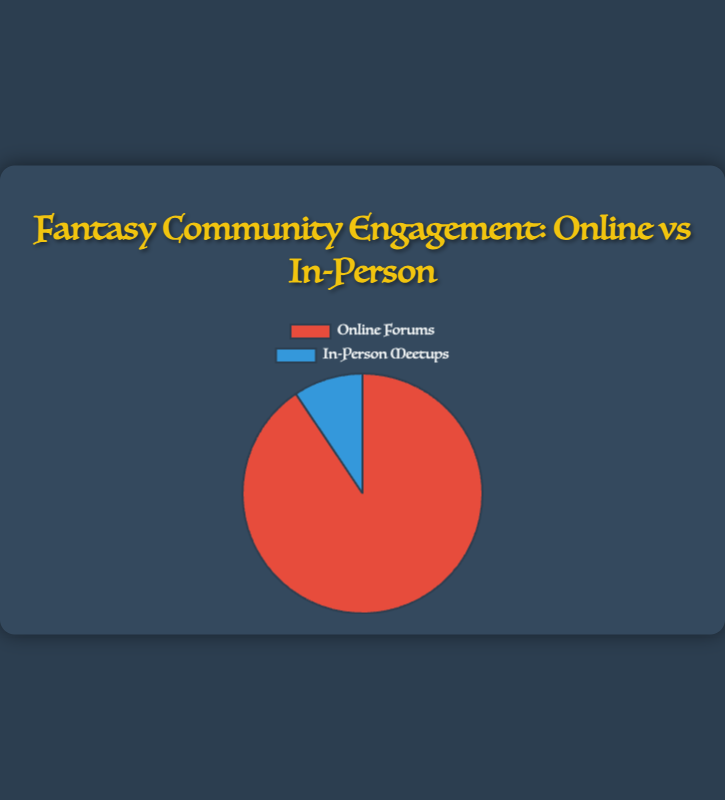What type of engagement has the highest average daily engagements? The pie chart shows two types of engagement: Online Forums and In-Person Meetups. Online Forums show a slice of the pie that is larger compared to the In-Person Meetups slice, indicating higher engagement.
Answer: Online Forums What is the total average daily engagement if you sum both Online Forums and In-Person Meetups? To find the total, you sum the average daily engagements for both categories: 14,000 (Online Forums) + 1,450 (In-Person Meetups) = 15,450.
Answer: 15,450 What percentage of the total engagement is attributed to In-Person Meetups? First, calculate the total engagement which is 14,000 + 1,450 = 15,450. Then, the percentage for In-Person Meetups is (1,450 / 15,450) * 100 = 9.39%.
Answer: 9.39% Which engagement type has a smaller visual segment in the pie chart? The chart visually shows a smaller segment for In-Person Meetups when compared to Online Forums.
Answer: In-Person Meetups How much greater is the engagement in Online Forums compared to In-Person Meetups? The difference between the average daily engagements is 14,000 (Online Forums) - 1,450 (In-Person Meetups) = 12,550.
Answer: 12,550 